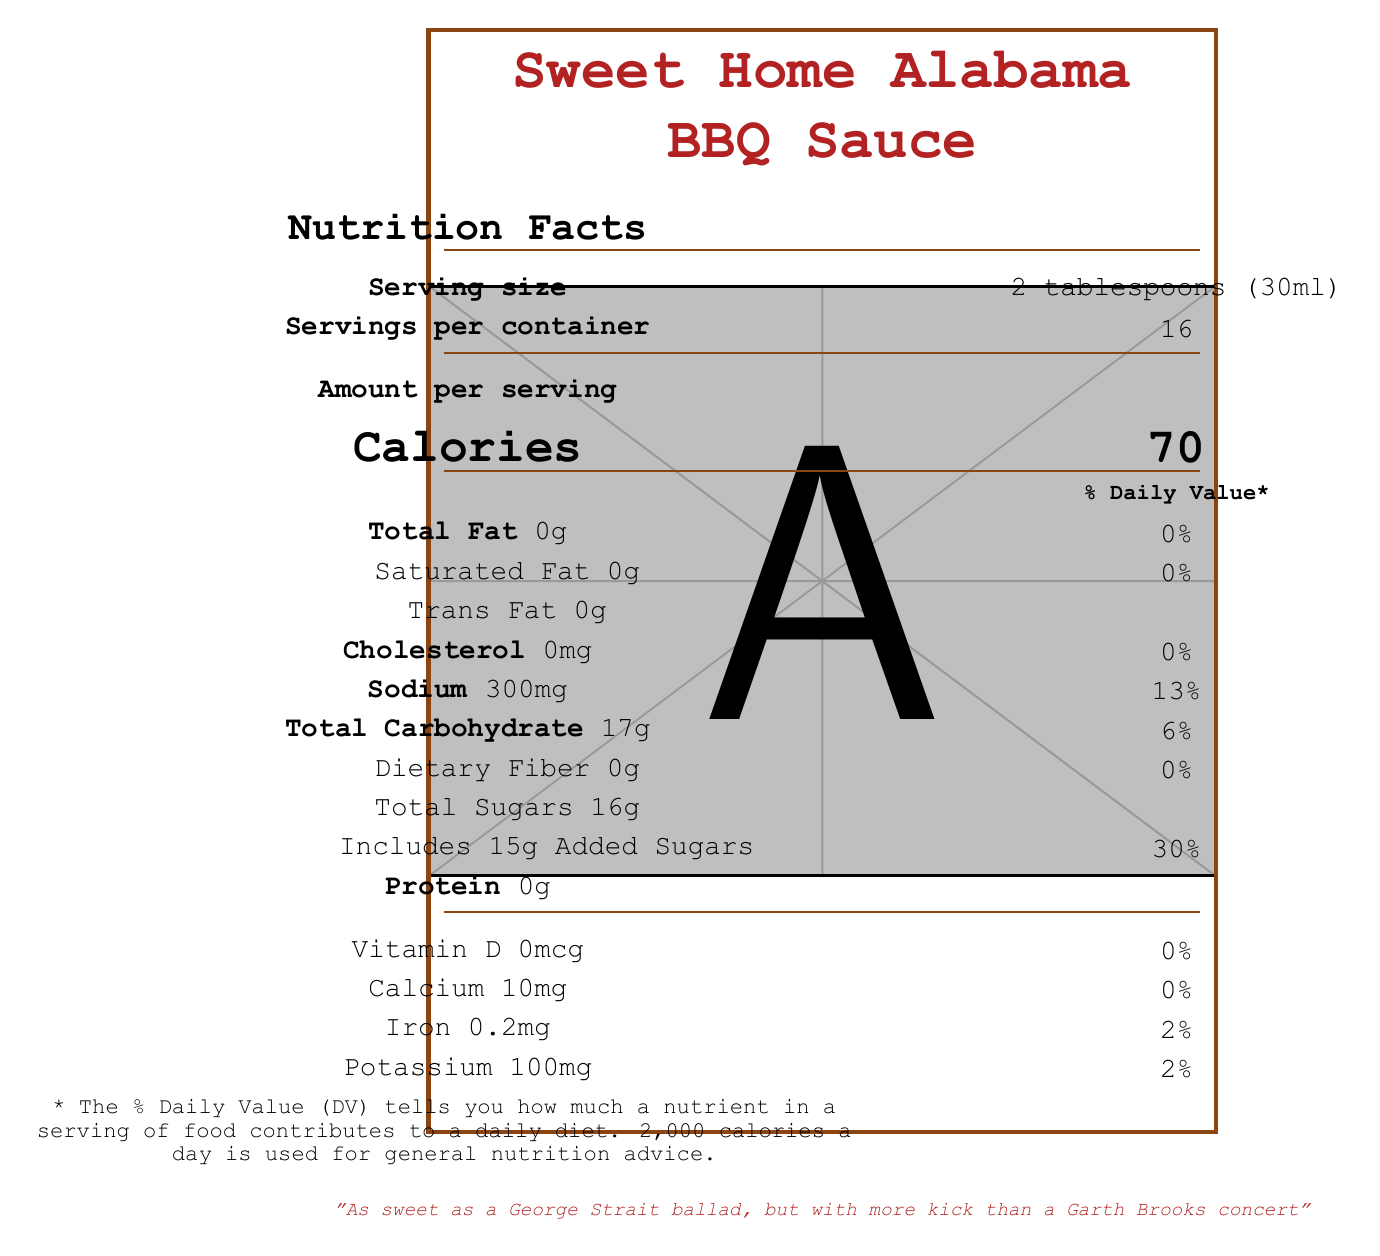what is the serving size of Sweet Home Alabama BBQ Sauce? The serving size is specified as "2 tablespoons (30ml)" under the section "Serving size".
Answer: 2 tablespoons (30ml) How many servings are there per container? The "Servings per container" is listed as 16.
Answer: 16 What are the total calories per serving? The "Calories" per serving is shown as 70 in the "Amount per serving" section.
Answer: 70 What is the total sugar content per serving? The document states "Total Sugars 16g" under the carbohydrates section.
Answer: 16g How much added sugar is included per serving? The added sugars per serving are explicitly indicated as "Includes 15g Added Sugars".
Answer: 15g Does the sauce contain any protein? The document specifies "Protein 0g" under the nutrients section.
Answer: No What percentage of the daily value of sodium does one serving have? The sodium content per serving is given as 300mg with a % Daily Value of 13%.
Answer: 13% How much calcium does a serving of this sauce provide? The document lists "Calcium 10mg" with a % Daily Value of 0%.
Answer: 10mg What is a notable ingredient in the Sweet Home Alabama BBQ Sauce? A. High fructose corn syrup B. Honey C. Soy sauce Among the listed ingredients, only "High fructose corn syrup" is present.
Answer: A How does this BBQ sauce compare to Dolly Parton's famous banana pudding in terms of sugar content? A. More sugar B. Less sugar C. The same amount of sugar The document states that the sauce contains more sugar per serving than a slice of Dolly Parton's famous banana pudding.
Answer: A Does the sauce contain any cholesterol? The sauce has "Cholesterol 0mg".
Answer: No Summarize the main nutritional highlights of the Sweet Home Alabama BBQ Sauce. This summary combines the main nutritional facts, including calories, fat, sodium, carbohydrates, sugars, and additional ingredients, as found in the document.
Answer: The Sweet Home Alabama BBQ Sauce has 70 calories per serving, contains 0g of fat, 300mg of sodium (13% DV), 17g of total carbohydrates with 16g of sugars and 15g of added sugars (30% DV), and 0g of protein. It also includes small amounts of calcium, iron, and potassium, and is made from ingredients like high fructose corn syrup, tomato paste, and molasses. Does the Sweet Home Alabama BBQ Sauce contain vitamin D? The document shows "Vitamin D 0mcg".
Answer: No Is this document endorsed by any country music artists? The disclaimer at the end states "Not endorsed by any country music artists, except maybe the ones SaraBeth opens for".
Answer: No What percentage of daily value for iron is in one serving? Iron content per serving is provided as 0.2mg, with a % Daily Value of 2%.
Answer: 2% What is the traditional pairing tip mentioned in the document? The document includes a section titled "traditionalPairingTip," which suggests pairing with pulled pork and classic Merle Haggard.
Answer: Perfect for slathering on pulled pork while listening to some classic Merle Haggard Is there any information about who designed this document? The document does not provide any information on who designed it.
Answer: Not enough information 